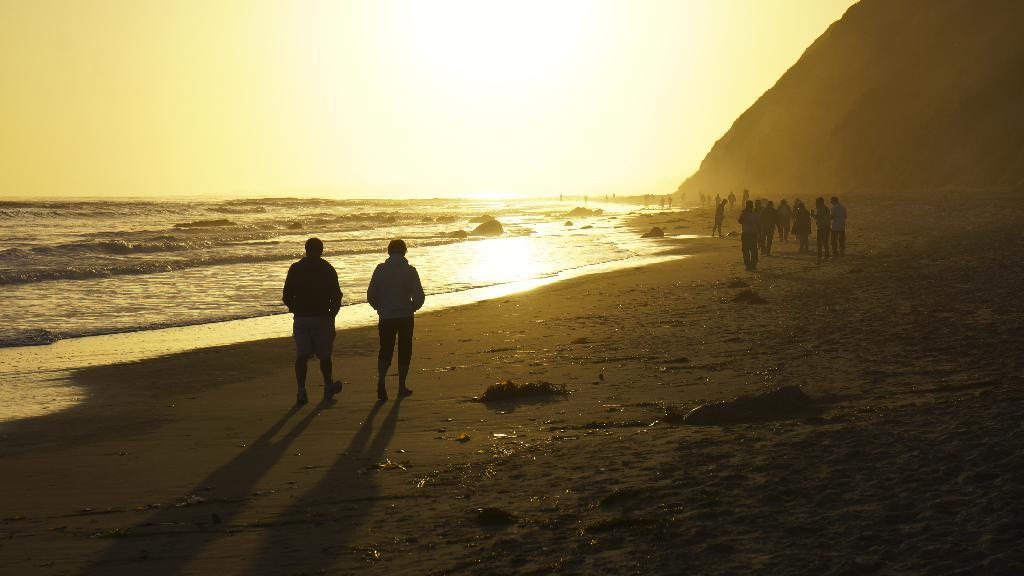What type of location is shown in the image? The image depicts a beach view. What are the people in the image doing? There are people walking on the sand in the front of the image. What natural feature is visible in the image? There is sea water visible in the image. What geographical feature can be seen in the right corner of the image? There is a huge mountain in the right corner of the image. What type of milk is being served at the camp in the image? There is no camp or milk present in the image; it depicts a beach view with people walking on the sand and a mountain in the background. 